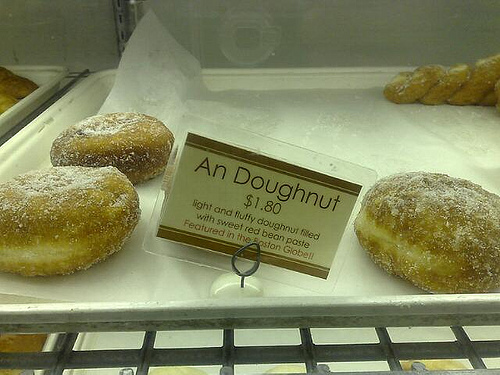Identify the text displayed in this image. An Doughnut 80 fluffy filled $I Globe the in with sw wish sweet, red beon paste doughnut and light 